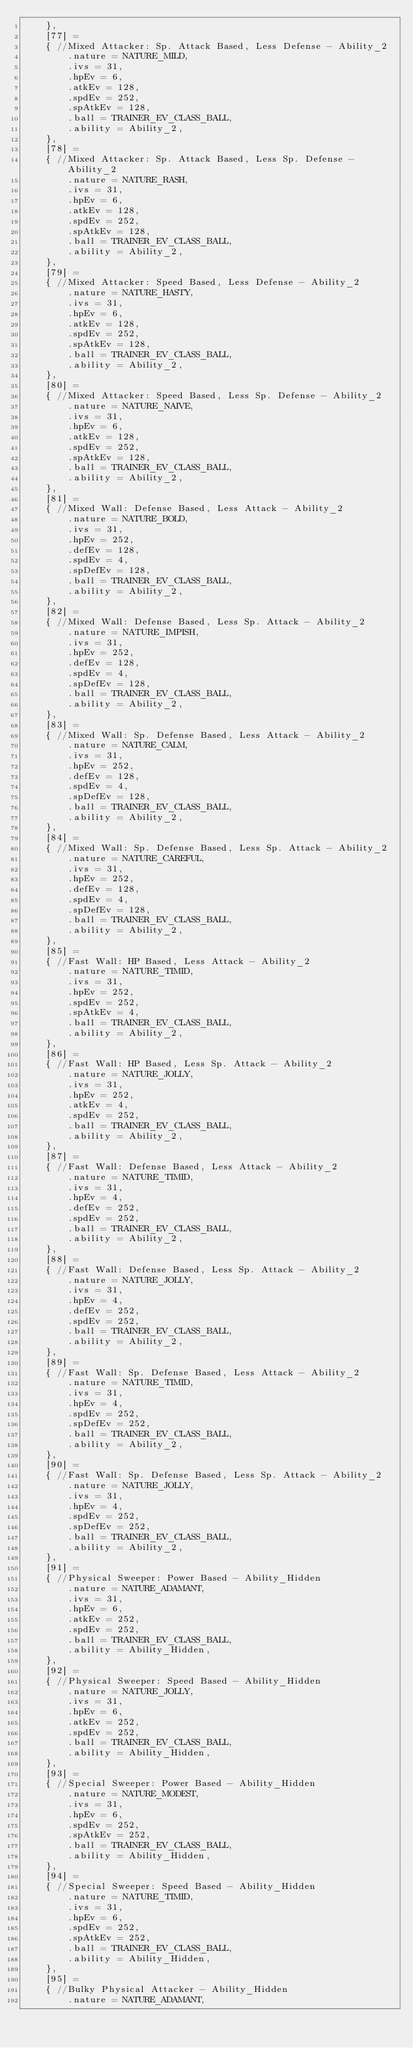Convert code to text. <code><loc_0><loc_0><loc_500><loc_500><_C_>	},
	[77] =
	{ //Mixed Attacker: Sp. Attack Based, Less Defense - Ability_2
		.nature = NATURE_MILD,
		.ivs = 31,
		.hpEv = 6,
		.atkEv = 128,
		.spdEv = 252,
		.spAtkEv = 128,
		.ball = TRAINER_EV_CLASS_BALL,
		.ability = Ability_2,
	},
	[78] =
	{ //Mixed Attacker: Sp. Attack Based, Less Sp. Defense - Ability_2
		.nature = NATURE_RASH,
		.ivs = 31,
		.hpEv = 6,
		.atkEv = 128,
		.spdEv = 252,
		.spAtkEv = 128,
		.ball = TRAINER_EV_CLASS_BALL,
		.ability = Ability_2,
	},
	[79] =
	{ //Mixed Attacker: Speed Based, Less Defense - Ability_2
		.nature = NATURE_HASTY,
		.ivs = 31,
		.hpEv = 6,
		.atkEv = 128,
		.spdEv = 252,
		.spAtkEv = 128,
		.ball = TRAINER_EV_CLASS_BALL,
		.ability = Ability_2,
	},
	[80] =
	{ //Mixed Attacker: Speed Based, Less Sp. Defense - Ability_2
		.nature = NATURE_NAIVE,
		.ivs = 31,
		.hpEv = 6,
		.atkEv = 128,
		.spdEv = 252,
		.spAtkEv = 128,
		.ball = TRAINER_EV_CLASS_BALL,
		.ability = Ability_2,
	},
	[81] =
	{ //Mixed Wall: Defense Based, Less Attack - Ability_2
		.nature = NATURE_BOLD,
		.ivs = 31,
		.hpEv = 252,
		.defEv = 128,
		.spdEv = 4,
		.spDefEv = 128,
		.ball = TRAINER_EV_CLASS_BALL,
		.ability = Ability_2,
	},
	[82] =
	{ //Mixed Wall: Defense Based, Less Sp. Attack - Ability_2
		.nature = NATURE_IMPISH,
		.ivs = 31,
		.hpEv = 252,
		.defEv = 128,
		.spdEv = 4,
		.spDefEv = 128,
		.ball = TRAINER_EV_CLASS_BALL,
		.ability = Ability_2,
	},
	[83] =
	{ //Mixed Wall: Sp. Defense Based, Less Attack - Ability_2
		.nature = NATURE_CALM,
		.ivs = 31,
		.hpEv = 252,
		.defEv = 128,
		.spdEv = 4,
		.spDefEv = 128,
		.ball = TRAINER_EV_CLASS_BALL,
		.ability = Ability_2,
	},
	[84] =
	{ //Mixed Wall: Sp. Defense Based, Less Sp. Attack - Ability_2
		.nature = NATURE_CAREFUL,
		.ivs = 31,
		.hpEv = 252,
		.defEv = 128,
		.spdEv = 4,
		.spDefEv = 128,
		.ball = TRAINER_EV_CLASS_BALL,
		.ability = Ability_2,
	},
	[85] =
	{ //Fast Wall: HP Based, Less Attack - Ability_2
		.nature = NATURE_TIMID,
		.ivs = 31,
		.hpEv = 252,
		.spdEv = 252,
		.spAtkEv = 4,
		.ball = TRAINER_EV_CLASS_BALL,
		.ability = Ability_2,
	},
	[86] =
	{ //Fast Wall: HP Based, Less Sp. Attack - Ability_2
		.nature = NATURE_JOLLY,
		.ivs = 31,
		.hpEv = 252,
		.atkEv = 4,
		.spdEv = 252,
		.ball = TRAINER_EV_CLASS_BALL,
		.ability = Ability_2,
	},
	[87] =
	{ //Fast Wall: Defense Based, Less Attack - Ability_2
		.nature = NATURE_TIMID,
		.ivs = 31,
		.hpEv = 4,
		.defEv = 252,
		.spdEv = 252,
		.ball = TRAINER_EV_CLASS_BALL,
		.ability = Ability_2,
	},
	[88] =
	{ //Fast Wall: Defense Based, Less Sp. Attack - Ability_2
		.nature = NATURE_JOLLY,
		.ivs = 31,
		.hpEv = 4,
		.defEv = 252,
		.spdEv = 252,
		.ball = TRAINER_EV_CLASS_BALL,
		.ability = Ability_2,
	},
	[89] =
	{ //Fast Wall: Sp. Defense Based, Less Attack - Ability_2
		.nature = NATURE_TIMID,
		.ivs = 31,
		.hpEv = 4,
		.spdEv = 252,
		.spDefEv = 252,
		.ball = TRAINER_EV_CLASS_BALL,
		.ability = Ability_2,
	},
	[90] =
	{ //Fast Wall: Sp. Defense Based, Less Sp. Attack - Ability_2
		.nature = NATURE_JOLLY,
		.ivs = 31,
		.hpEv = 4,
		.spdEv = 252,
		.spDefEv = 252,
		.ball = TRAINER_EV_CLASS_BALL,
		.ability = Ability_2,
	},
	[91] =
	{ //Physical Sweeper: Power Based - Ability_Hidden
		.nature = NATURE_ADAMANT,
		.ivs = 31,
		.hpEv = 6,
		.atkEv = 252,
		.spdEv = 252,
		.ball = TRAINER_EV_CLASS_BALL,
		.ability = Ability_Hidden,
	},
	[92] =
	{ //Physical Sweeper: Speed Based - Ability_Hidden
		.nature = NATURE_JOLLY,
		.ivs = 31,
		.hpEv = 6,
		.atkEv = 252,
		.spdEv = 252,
		.ball = TRAINER_EV_CLASS_BALL,
		.ability = Ability_Hidden,
	},
	[93] =
	{ //Special Sweeper: Power Based - Ability_Hidden
		.nature = NATURE_MODEST,
		.ivs = 31,
		.hpEv = 6,
		.spdEv = 252,
		.spAtkEv = 252,
		.ball = TRAINER_EV_CLASS_BALL,
		.ability = Ability_Hidden,
	},
	[94] =
	{ //Special Sweeper: Speed Based - Ability_Hidden
		.nature = NATURE_TIMID,
		.ivs = 31,
		.hpEv = 6,
		.spdEv = 252,
		.spAtkEv = 252,
		.ball = TRAINER_EV_CLASS_BALL,
		.ability = Ability_Hidden,
	},
	[95] =
	{ //Bulky Physical Attacker - Ability_Hidden
		.nature = NATURE_ADAMANT,</code> 